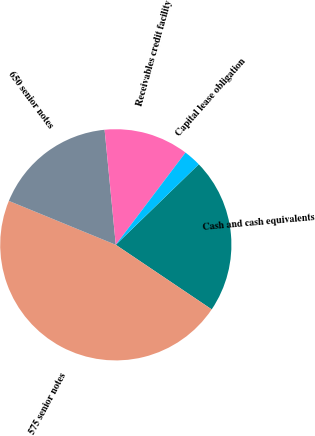<chart> <loc_0><loc_0><loc_500><loc_500><pie_chart><fcel>Cash and cash equivalents<fcel>575 senior notes<fcel>650 senior notes<fcel>Receivables credit facility<fcel>Capital lease obligation<nl><fcel>21.69%<fcel>46.77%<fcel>17.25%<fcel>11.84%<fcel>2.44%<nl></chart> 